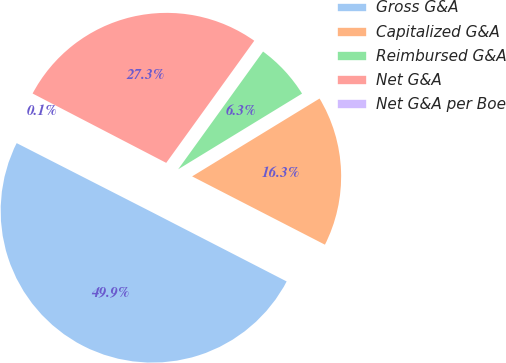Convert chart to OTSL. <chart><loc_0><loc_0><loc_500><loc_500><pie_chart><fcel>Gross G&A<fcel>Capitalized G&A<fcel>Reimbursed G&A<fcel>Net G&A<fcel>Net G&A per Boe<nl><fcel>49.95%<fcel>16.29%<fcel>6.33%<fcel>27.32%<fcel>0.11%<nl></chart> 